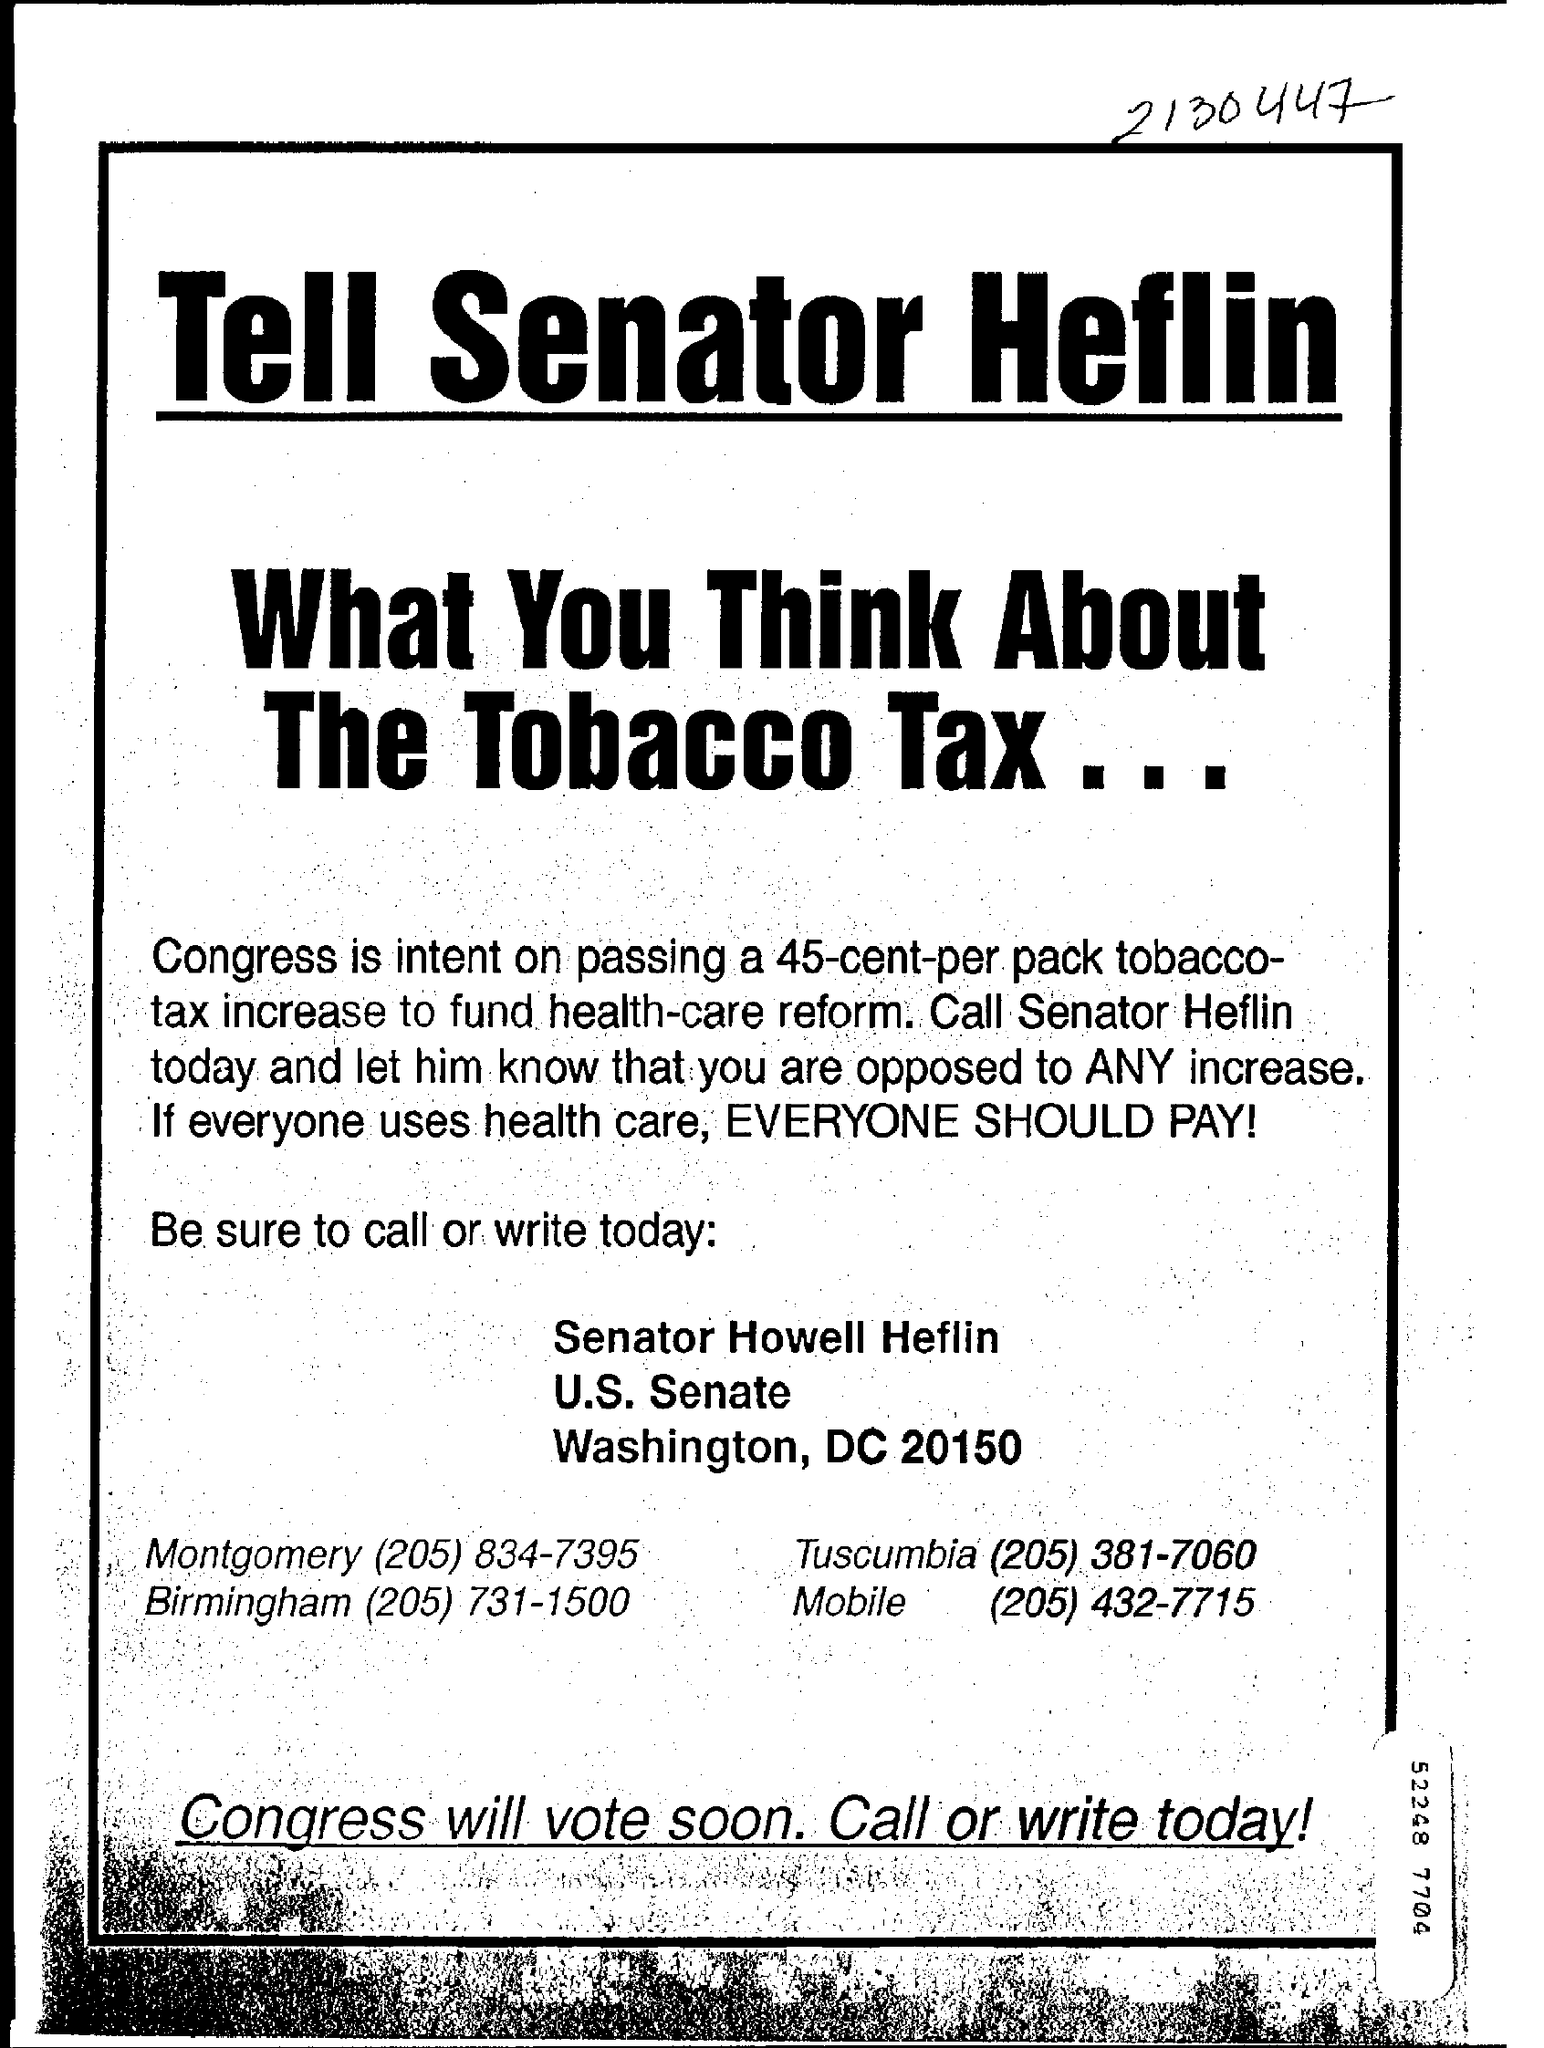Highlight a few significant elements in this photo. Congress is intent on passing a significant tax increase, which would increase the price of cigarettes by 45 cents per pack. The mobile number mentioned is (205) 432-7715. 